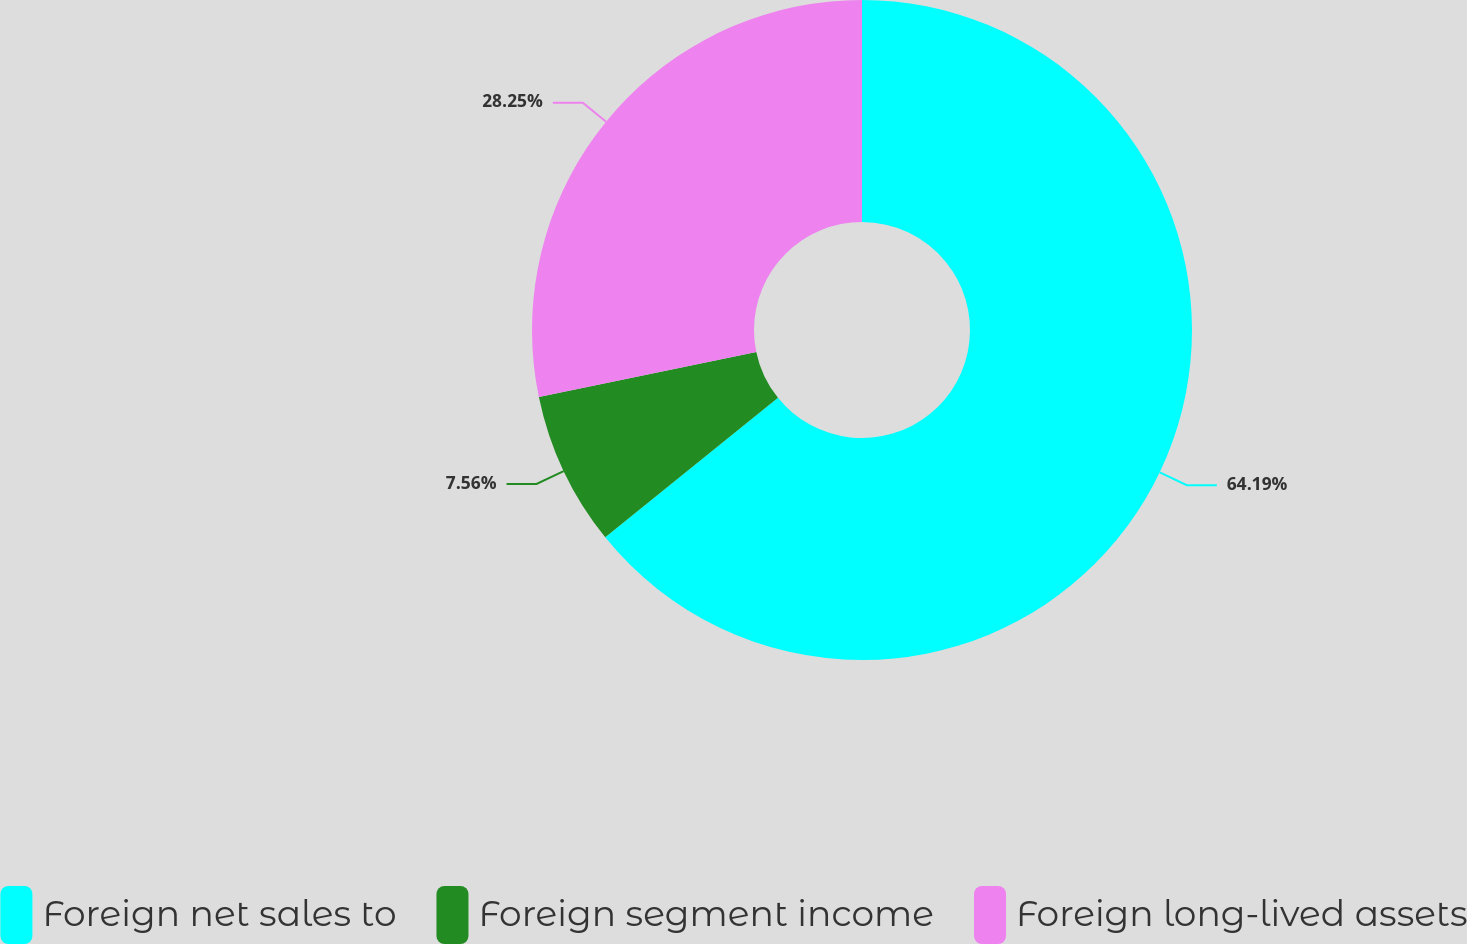<chart> <loc_0><loc_0><loc_500><loc_500><pie_chart><fcel>Foreign net sales to<fcel>Foreign segment income<fcel>Foreign long-lived assets<nl><fcel>64.19%<fcel>7.56%<fcel>28.25%<nl></chart> 